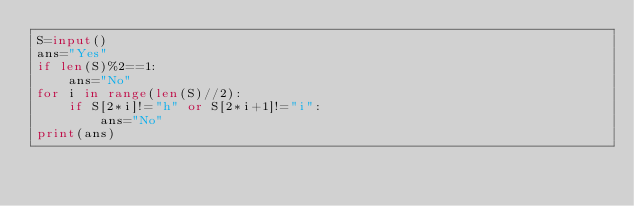Convert code to text. <code><loc_0><loc_0><loc_500><loc_500><_Python_>S=input()
ans="Yes"
if len(S)%2==1:
    ans="No"
for i in range(len(S)//2):
    if S[2*i]!="h" or S[2*i+1]!="i":
        ans="No"
print(ans)</code> 